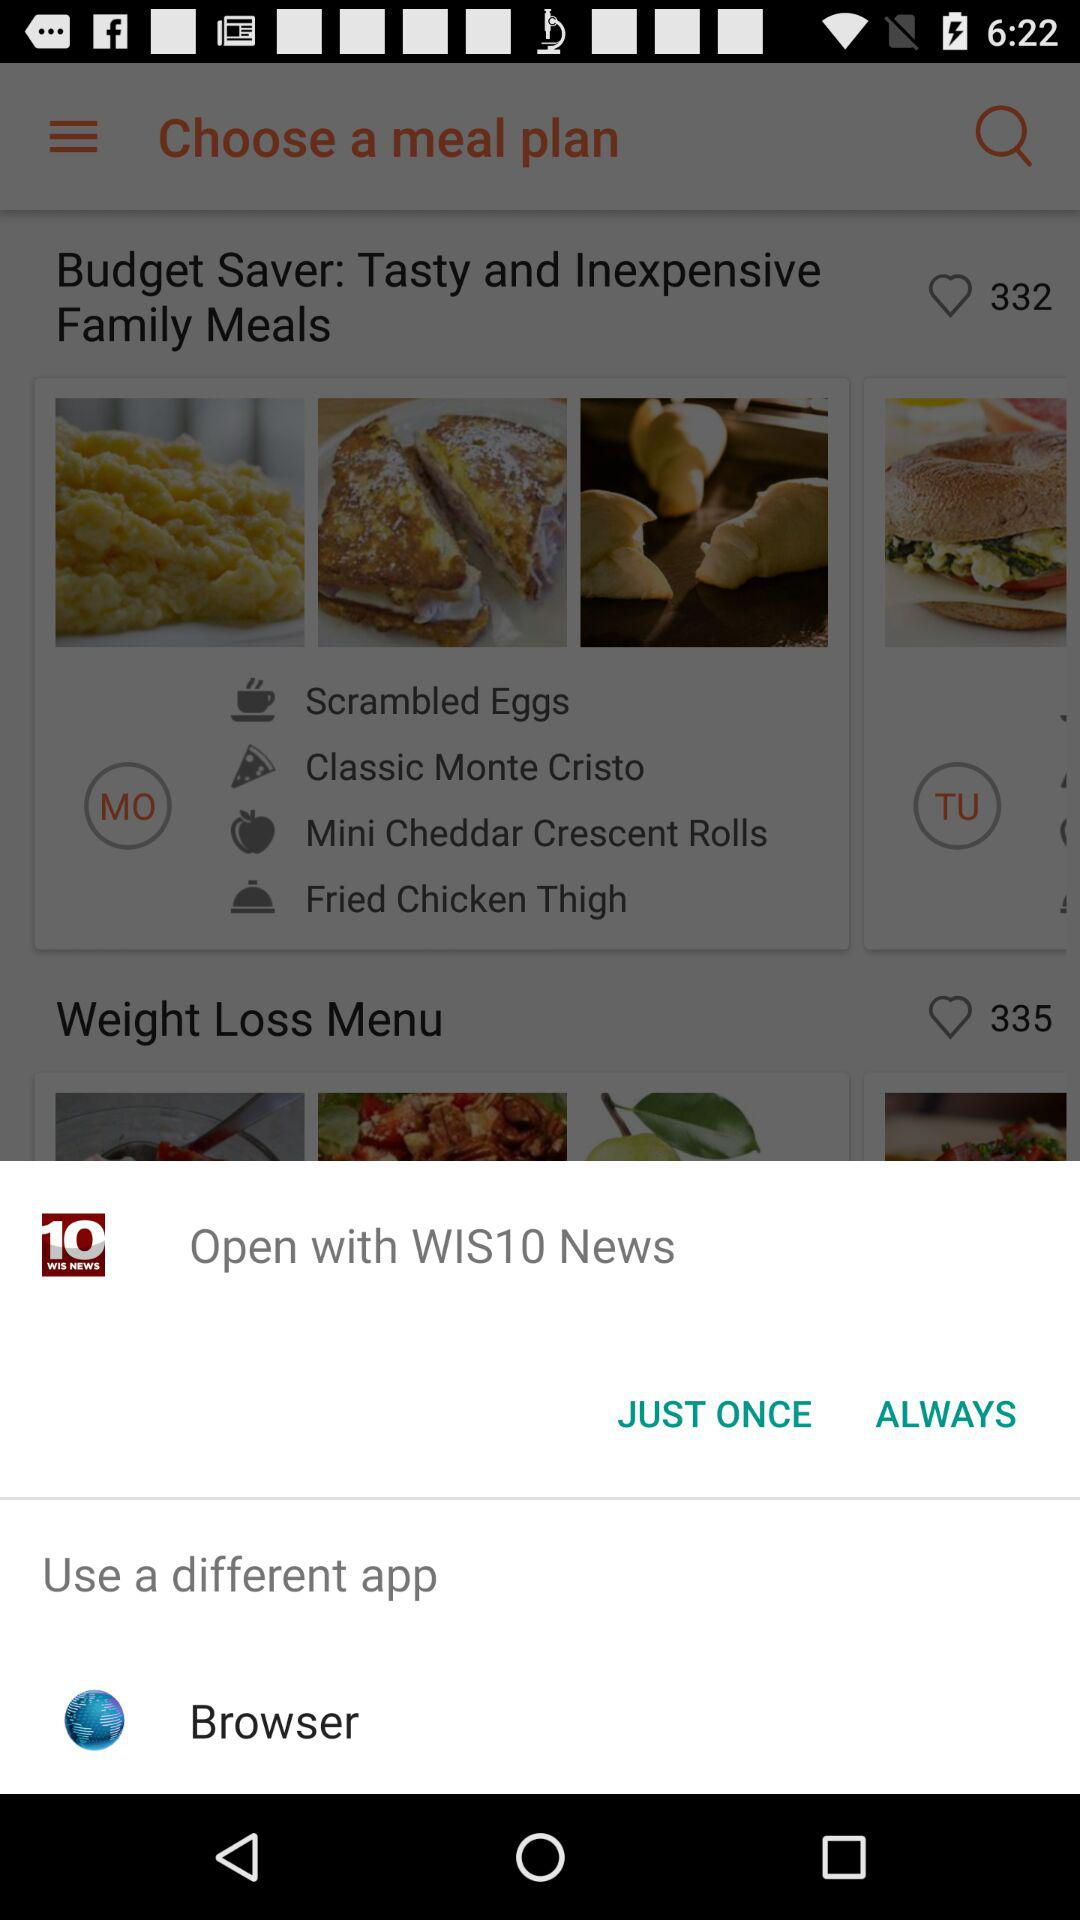Where can i open the WIS10 News?
When the provided information is insufficient, respond with <no answer>. <no answer> 